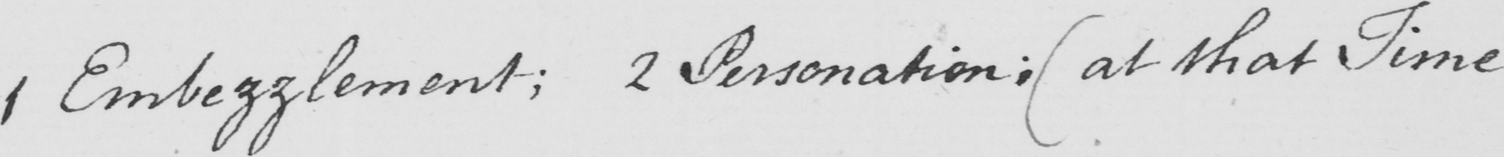Can you tell me what this handwritten text says? 1 Embezzlement ; 2 Personation ;  ( at that Time 